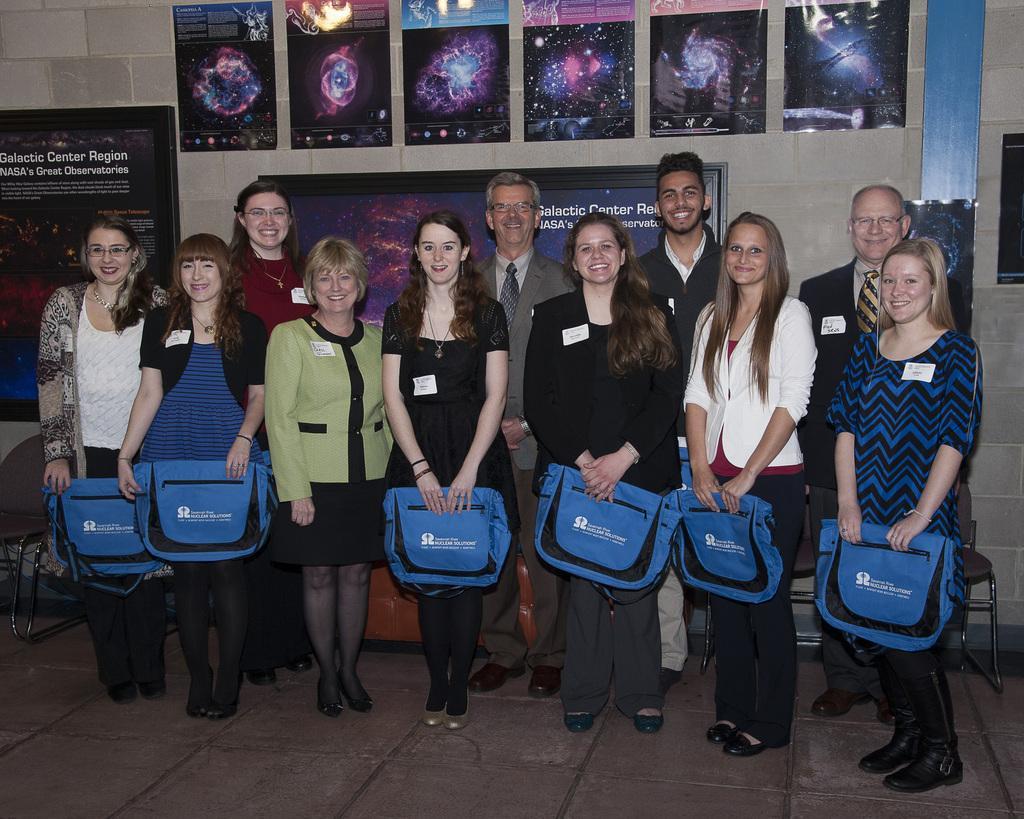Please provide a concise description of this image. In the picture we can see some women are standing and holding some bags which are blue in color and behind them, we can see some people are standing and smiling and in the background, we can see a wall with some posters of animation pictures and we can also see some hoardings and board to it. 